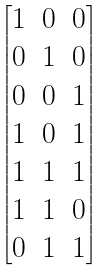Convert formula to latex. <formula><loc_0><loc_0><loc_500><loc_500>\begin{bmatrix} 1 & 0 & 0 \\ 0 & 1 & 0 \\ 0 & 0 & 1 \\ 1 & 0 & 1 \\ 1 & 1 & 1 \\ 1 & 1 & 0 \\ 0 & 1 & 1 \\ \end{bmatrix}</formula> 